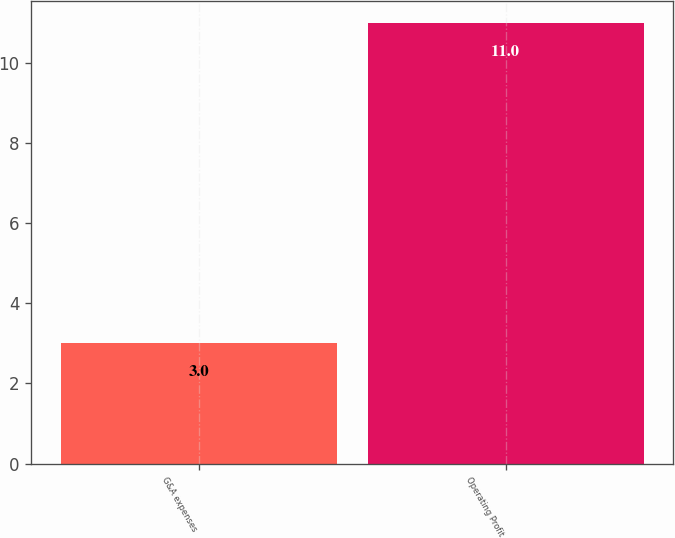Convert chart to OTSL. <chart><loc_0><loc_0><loc_500><loc_500><bar_chart><fcel>G&A expenses<fcel>Operating Profit<nl><fcel>3<fcel>11<nl></chart> 